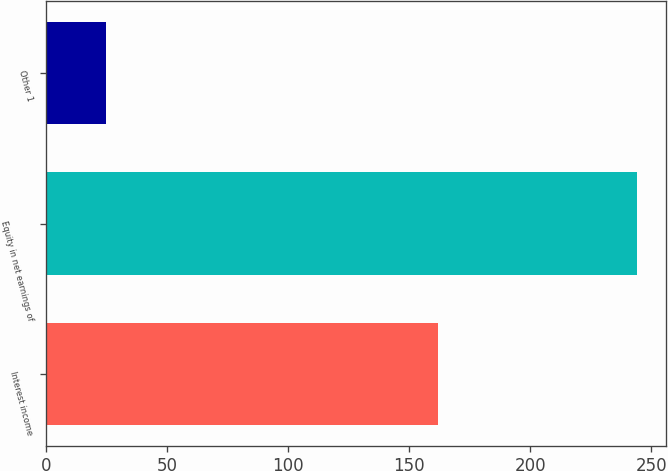Convert chart to OTSL. <chart><loc_0><loc_0><loc_500><loc_500><bar_chart><fcel>Interest income<fcel>Equity in net earnings of<fcel>Other 1<nl><fcel>162<fcel>244<fcel>25<nl></chart> 